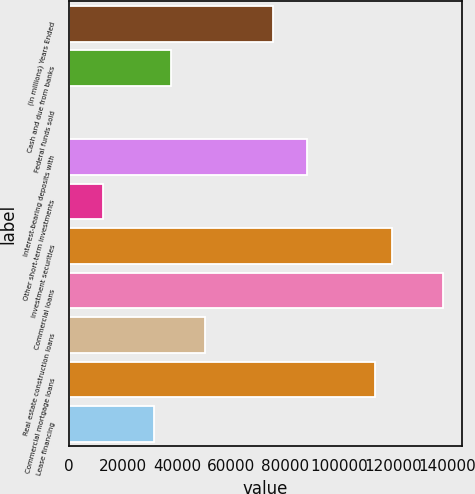Convert chart. <chart><loc_0><loc_0><loc_500><loc_500><bar_chart><fcel>(in millions) Years Ended<fcel>Cash and due from banks<fcel>Federal funds sold<fcel>Interest-bearing deposits with<fcel>Other short-term investments<fcel>Investment securities<fcel>Commercial loans<fcel>Real estate construction loans<fcel>Commercial mortgage loans<fcel>Lease financing<nl><fcel>75422.6<fcel>37719.8<fcel>17<fcel>87990.2<fcel>12584.6<fcel>119409<fcel>138261<fcel>50287.4<fcel>113125<fcel>31436<nl></chart> 